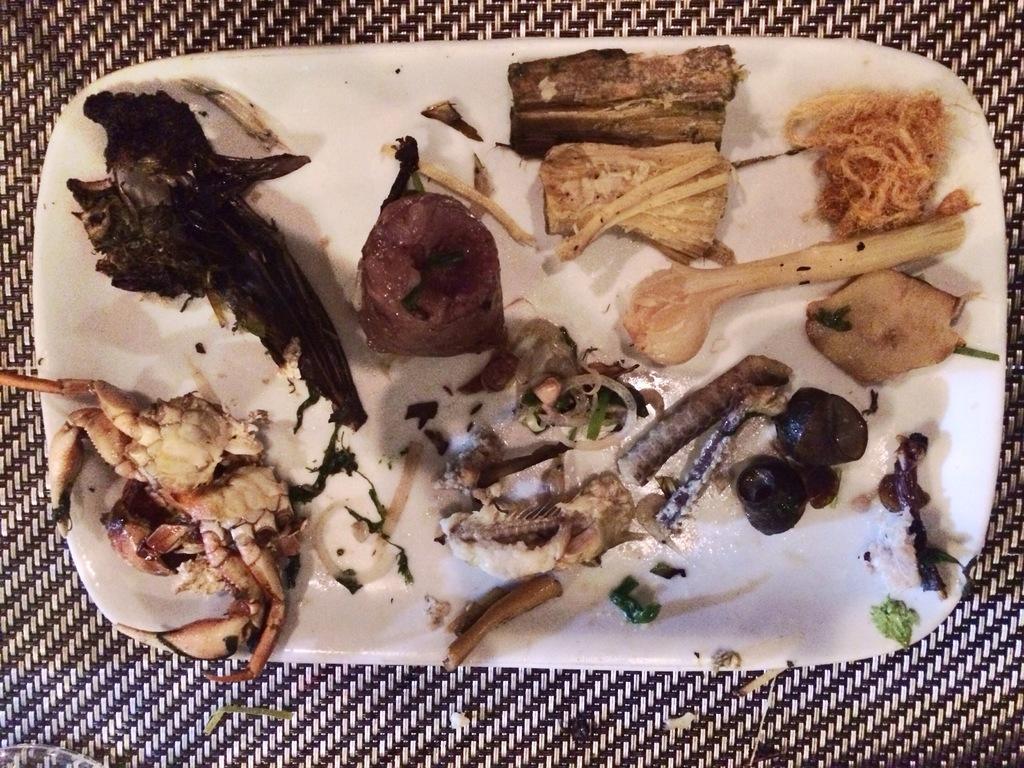Describe this image in one or two sentences. In this picture we can see food items placed on the white plate and this plate is placed on the surface. 